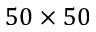Convert formula to latex. <formula><loc_0><loc_0><loc_500><loc_500>5 0 \times 5 0</formula> 